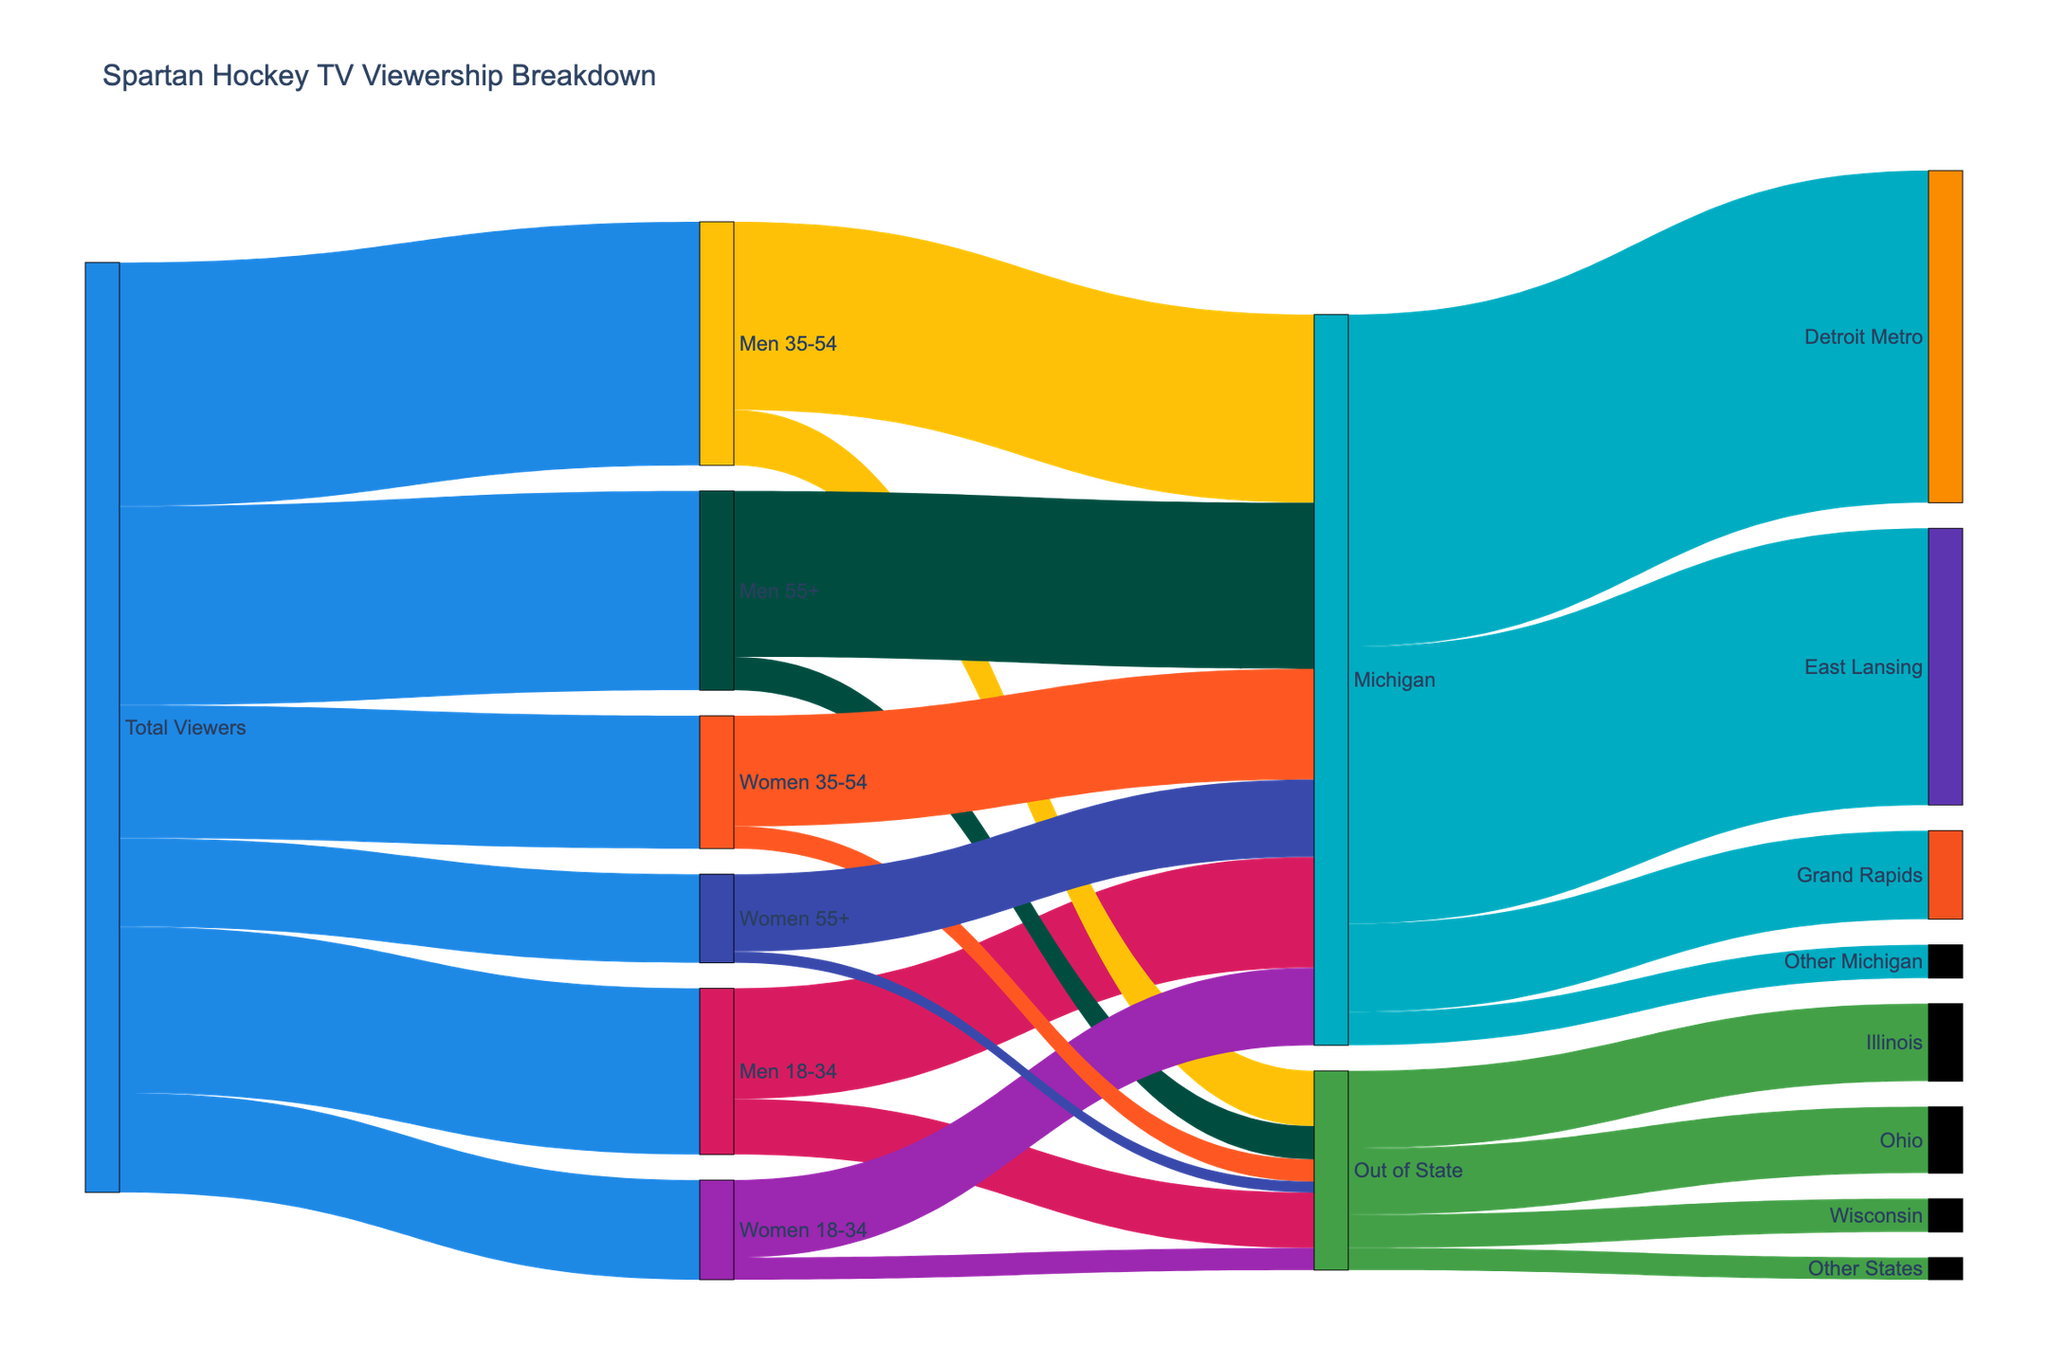Which demographic has the highest viewership? Look at the Sankey diagram and find the demographic with the largest connection from "Total Viewers."
Answer: Men 35-54 Which location in Michigan has the highest viewership? From the nodes connected to "Michigan," identify which location node has the highest value.
Answer: Detroit Metro What is the total viewership for women? Sum the viewership values for all women demographics: Women 18-34, Women 35-54, and Women 55+. Add 9000 + 12000 + 8000.
Answer: 29000 Which group has more out-of-state viewers, Men 18-34 or Men 35-54? Compare the values connected to "Out of State" from "Men 18-34" and "Men 35-54" nodes.
Answer: Men 18-34 How many viewers from Michigan are aged 55 and older? Sum the "Michigan" values from "Men 55+" and "Women 55+" nodes: 15000 + 7000.
Answer: 22000 Which location has more viewers, East Lansing or Grand Rapids? Compare the viewership values from the nodes "East Lansing" and "Grand Rapids."
Answer: East Lansing What is the total viewership for people aged 35-54? Sum the viewership values for "Men 35-54" and "Women 35-54": 22000 + 12000.
Answer: 34000 On average, do more men or women watch Spartan hockey? Calculate average viewership for men and women. Total men viewership: 15000 + 22000 + 18000 = 55000. Total women viewership: 9000 + 12000 + 8000 = 29000. Compare the totals.
Answer: Men Which out-of-state location has the lowest viewership? Identify the smallest value among the out-of-state locations: Illinois, Ohio, Wisconsin, Other States.
Answer: Other States What percentage of total viewership is from viewers aged 18-34? Sum "Men 18-34" and "Women 18-34" viewerships: 15000 + 9000 = 24000. Calculate the percentage with respect to total viewership: (24000 / 84000) * 100.
Answer: 28.57% 